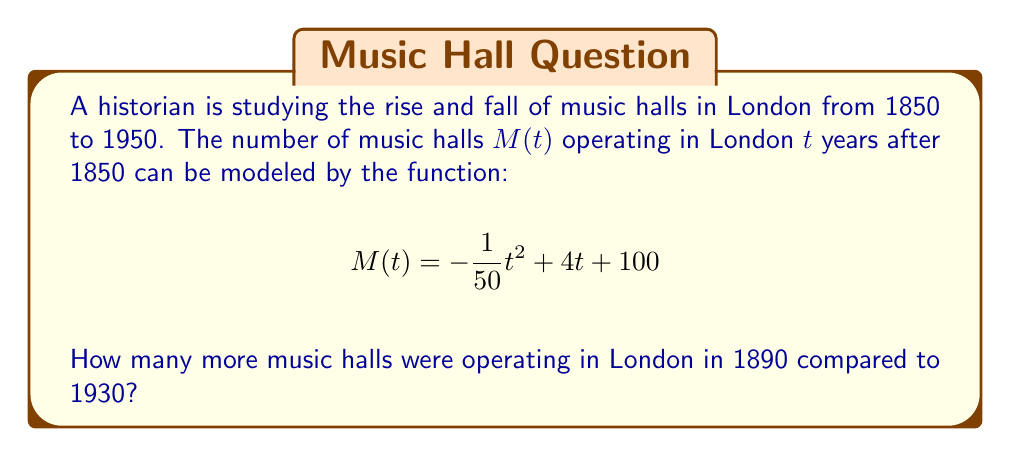Can you solve this math problem? To solve this problem, we need to follow these steps:

1) First, we need to calculate the number of years after 1850 for both 1890 and 1930:
   For 1890: $t_1 = 1890 - 1850 = 40$ years
   For 1930: $t_2 = 1930 - 1850 = 80$ years

2) Now, we can plug these values into our function $M(t)$:

   For 1890 ($t = 40$):
   $$M(40) = -\frac{1}{50}(40)^2 + 4(40) + 100$$
   $$= -\frac{1600}{50} + 160 + 100$$
   $$= -32 + 160 + 100 = 228$$

   For 1930 ($t = 80$):
   $$M(80) = -\frac{1}{50}(80)^2 + 4(80) + 100$$
   $$= -\frac{6400}{50} + 320 + 100$$
   $$= -128 + 320 + 100 = 292$$

3) To find how many more music halls were operating in 1890 compared to 1930, we subtract:

   $$228 - 292 = -64$$

The negative result indicates that there were actually fewer music halls in 1890 than in 1930.

4) To express this as a positive number of additional halls in 1930, we take the absolute value:

   $$|228 - 292| = 64$$
Answer: 64 